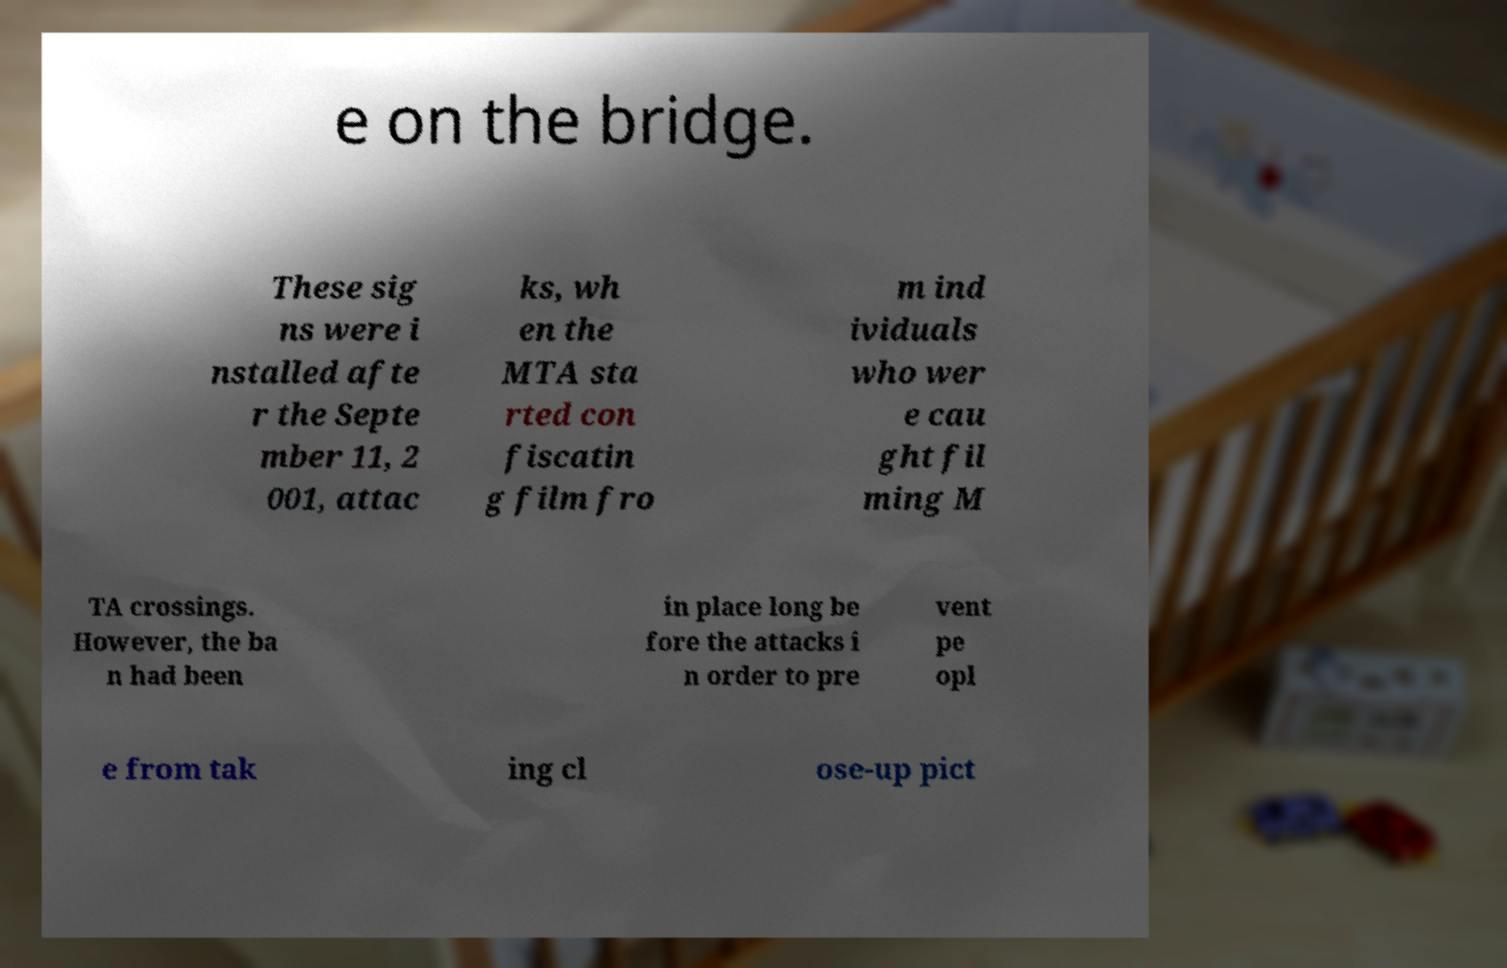Please read and relay the text visible in this image. What does it say? e on the bridge. These sig ns were i nstalled afte r the Septe mber 11, 2 001, attac ks, wh en the MTA sta rted con fiscatin g film fro m ind ividuals who wer e cau ght fil ming M TA crossings. However, the ba n had been in place long be fore the attacks i n order to pre vent pe opl e from tak ing cl ose-up pict 